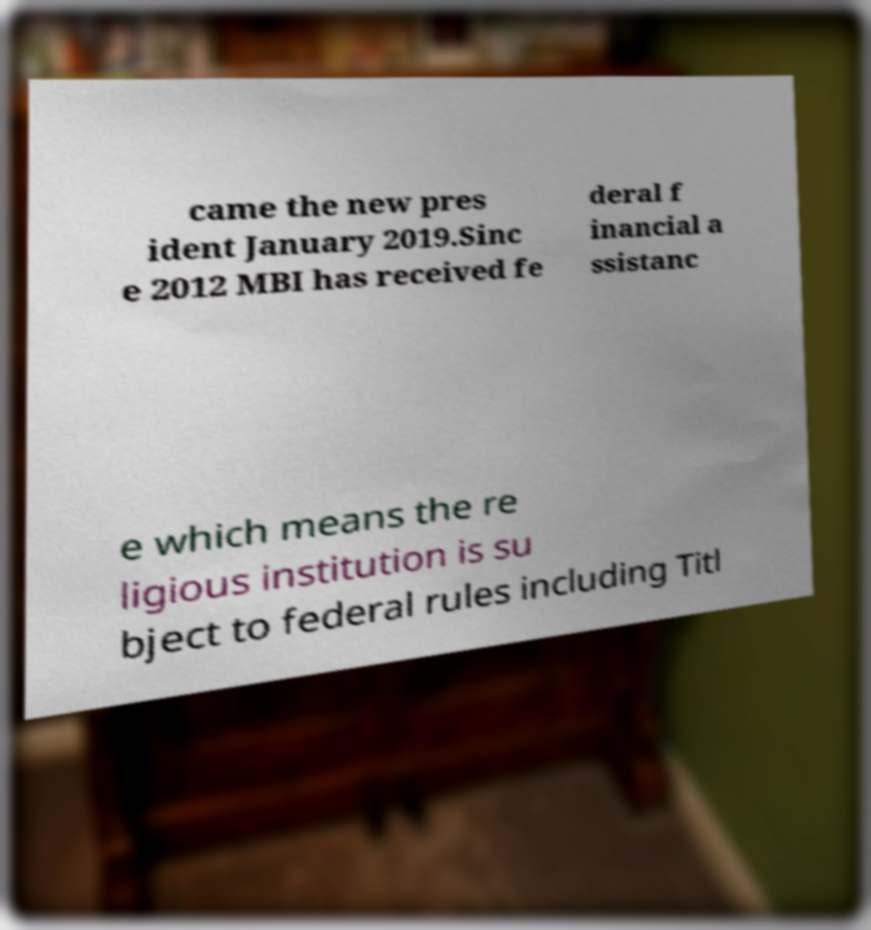What messages or text are displayed in this image? I need them in a readable, typed format. came the new pres ident January 2019.Sinc e 2012 MBI has received fe deral f inancial a ssistanc e which means the re ligious institution is su bject to federal rules including Titl 